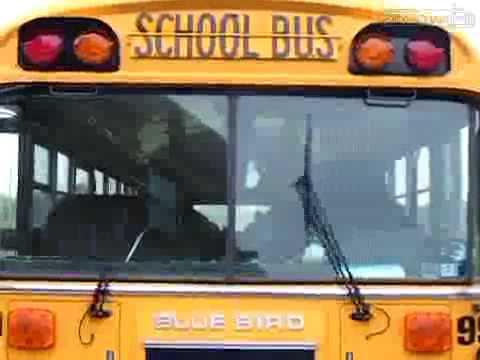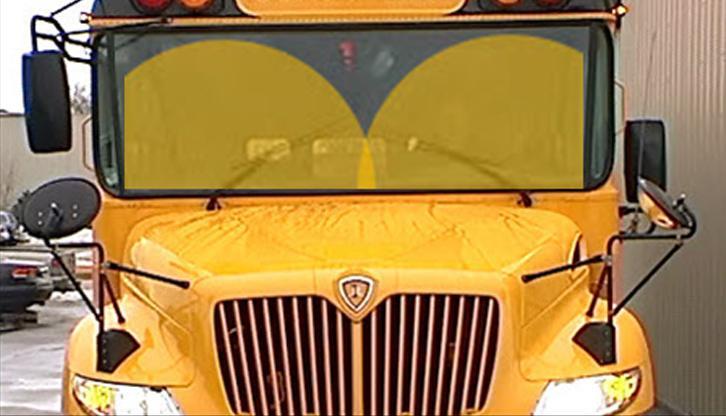The first image is the image on the left, the second image is the image on the right. Evaluate the accuracy of this statement regarding the images: "In at least one image there is a single view of a flat front end bus with its windshield wiper up.". Is it true? Answer yes or no. Yes. The first image is the image on the left, the second image is the image on the right. For the images displayed, is the sentence "At least one of the images shows a bus from the right side and its stop sign is visible." factually correct? Answer yes or no. No. 